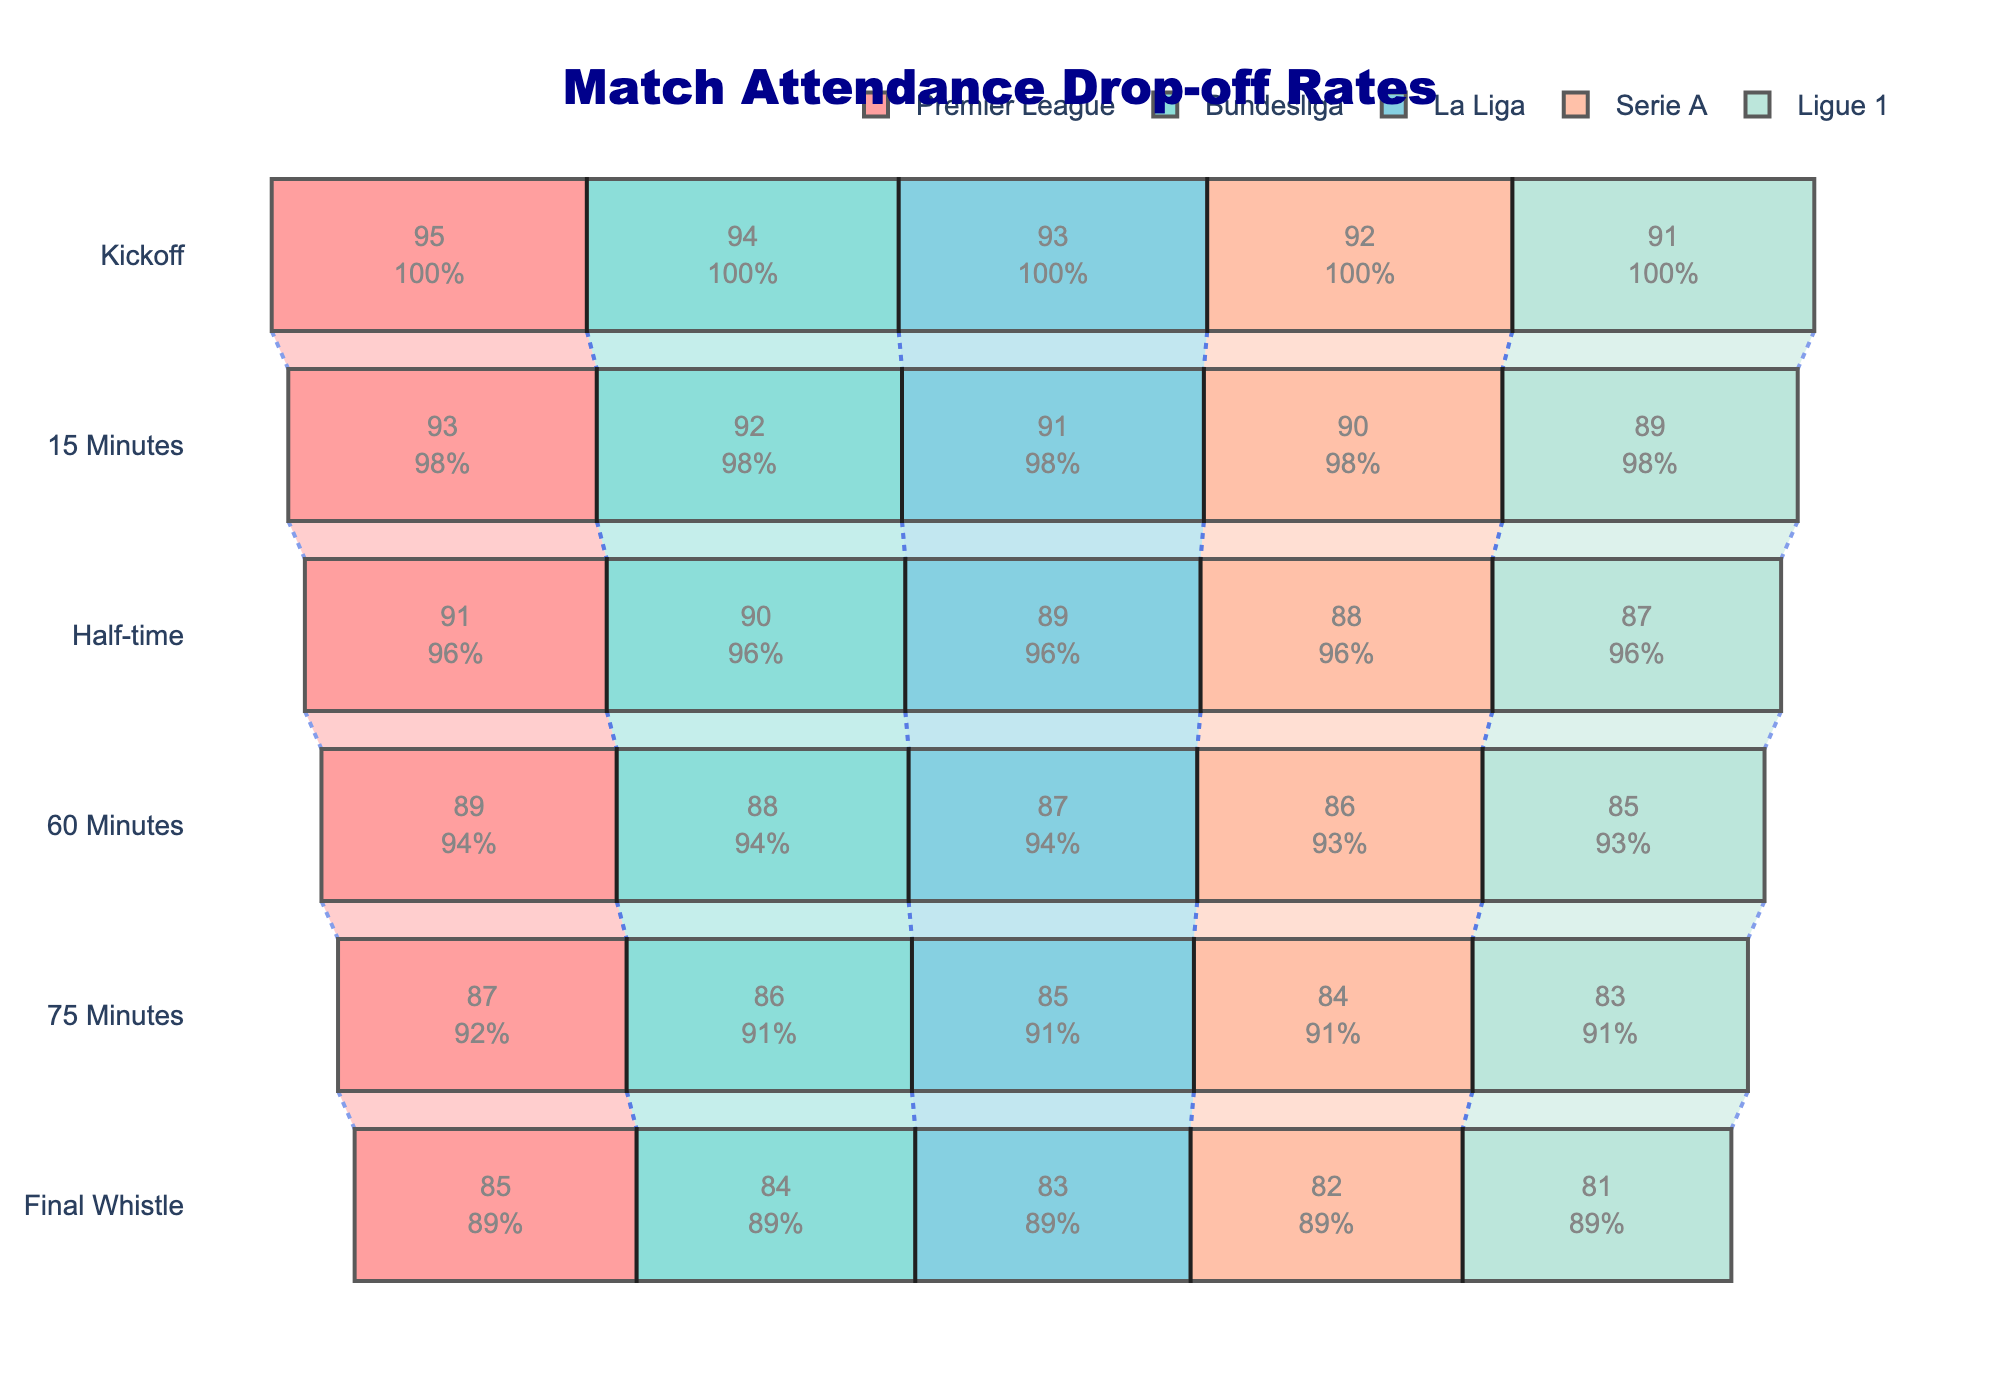What's the title of the figure? The title of the figure is usually placed at the top and is easily readable. In this case, the title is written clearly as "Match Attendance Drop-off Rates".
Answer: Match Attendance Drop-off Rates How many stages are shown in the chart? The funnel chart indicates stages on the y-axis, which are indicators of different times during the match. There are six points in time shown: Kickoff, 15 Minutes, Half-time, 60 Minutes, 75 Minutes, and Final Whistle.
Answer: Six By how much does attendance drop from Kickoff to Final Whistle in the Premier League? To find the drop: subtract the Final Whistle percentage from the Kickoff percentage. For the Premier League, attendance drops from 95% to 85%. The drop is 95% - 85% = 10%.
Answer: 10% Which league has the highest attendance drop-off at Half-time? By comparing attendance percentages at Half-time, the league with the lowest percentage of attendance indicates the highest drop-off. Ligue 1 has the lowest percentage at 87%.
Answer: Ligue 1 Which league maintains the highest overall attendance from Kickoff to Final Whistle? Looking at the final percentages, the league with the highest value at the Final Whistle maintains the highest attendance. The Premier League ends at 85%, which is higher than the others.
Answer: Premier League What is the average attendance at 60 Minutes across all leagues? To find the average, sum the attendance percentages at 60 Minutes for all leagues and divide by the number of leagues: (89 + 88 + 87 + 86 + 85) / 5 = 87%.
Answer: 87% What is the percentage difference in attendance between 15 Minutes and 75 Minutes in Serie A? Calculate the difference: attendance at 15 Minutes is 90% and at 75 Minutes is 84%, so the difference is 90% - 84% = 6%.
Answer: 6% Which league shows the second smallest drop-off from Kickoff to 15 Minutes? To determine this, calculate the drop-off for each league: Premier League (2%), Bundesliga (2%), La Liga (2%), Serie A (2%), Ligue 1 (2%). All have the same drop-off, so they're all equally second smallest.
Answer: All leagues (2%) Which stage sees the largest retention rate for Bundesliga? The retention rate is observed as the percentage of attendance at each stage, with earlier stages having higher percentages. Kickoff has the highest retention rate at 94%.
Answer: Kickoff By how much does La Liga’s attendance change from Half-time to 60 Minutes? Calculate the change: attendance at Half-time is 89%, and at 60 Minutes it is 87%, so the change is 89% - 87% = 2%.
Answer: 2% 